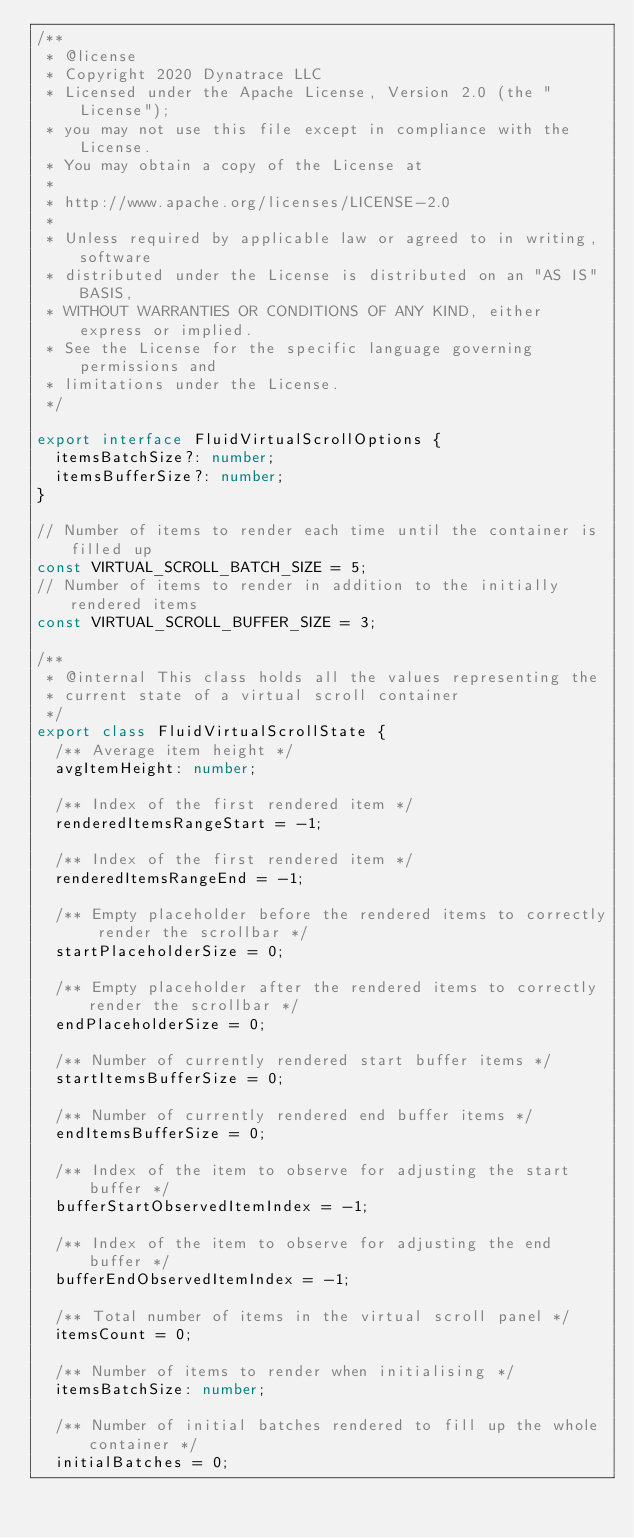Convert code to text. <code><loc_0><loc_0><loc_500><loc_500><_TypeScript_>/**
 * @license
 * Copyright 2020 Dynatrace LLC
 * Licensed under the Apache License, Version 2.0 (the "License");
 * you may not use this file except in compliance with the License.
 * You may obtain a copy of the License at
 *
 * http://www.apache.org/licenses/LICENSE-2.0
 *
 * Unless required by applicable law or agreed to in writing, software
 * distributed under the License is distributed on an "AS IS" BASIS,
 * WITHOUT WARRANTIES OR CONDITIONS OF ANY KIND, either express or implied.
 * See the License for the specific language governing permissions and
 * limitations under the License.
 */

export interface FluidVirtualScrollOptions {
  itemsBatchSize?: number;
  itemsBufferSize?: number;
}

// Number of items to render each time until the container is filled up
const VIRTUAL_SCROLL_BATCH_SIZE = 5;
// Number of items to render in addition to the initially rendered items
const VIRTUAL_SCROLL_BUFFER_SIZE = 3;

/**
 * @internal This class holds all the values representing the
 * current state of a virtual scroll container
 */
export class FluidVirtualScrollState {
  /** Average item height */
  avgItemHeight: number;

  /** Index of the first rendered item */
  renderedItemsRangeStart = -1;

  /** Index of the first rendered item */
  renderedItemsRangeEnd = -1;

  /** Empty placeholder before the rendered items to correctly render the scrollbar */
  startPlaceholderSize = 0;

  /** Empty placeholder after the rendered items to correctly render the scrollbar */
  endPlaceholderSize = 0;

  /** Number of currently rendered start buffer items */
  startItemsBufferSize = 0;

  /** Number of currently rendered end buffer items */
  endItemsBufferSize = 0;

  /** Index of the item to observe for adjusting the start buffer */
  bufferStartObservedItemIndex = -1;

  /** Index of the item to observe for adjusting the end buffer */
  bufferEndObservedItemIndex = -1;

  /** Total number of items in the virtual scroll panel */
  itemsCount = 0;

  /** Number of items to render when initialising */
  itemsBatchSize: number;

  /** Number of initial batches rendered to fill up the whole container */
  initialBatches = 0;
</code> 